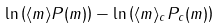Convert formula to latex. <formula><loc_0><loc_0><loc_500><loc_500>\ln \left ( \langle m \rangle P ( m ) \right ) - \ln \left ( \langle m \rangle _ { c } P _ { c } ( m ) \right )</formula> 